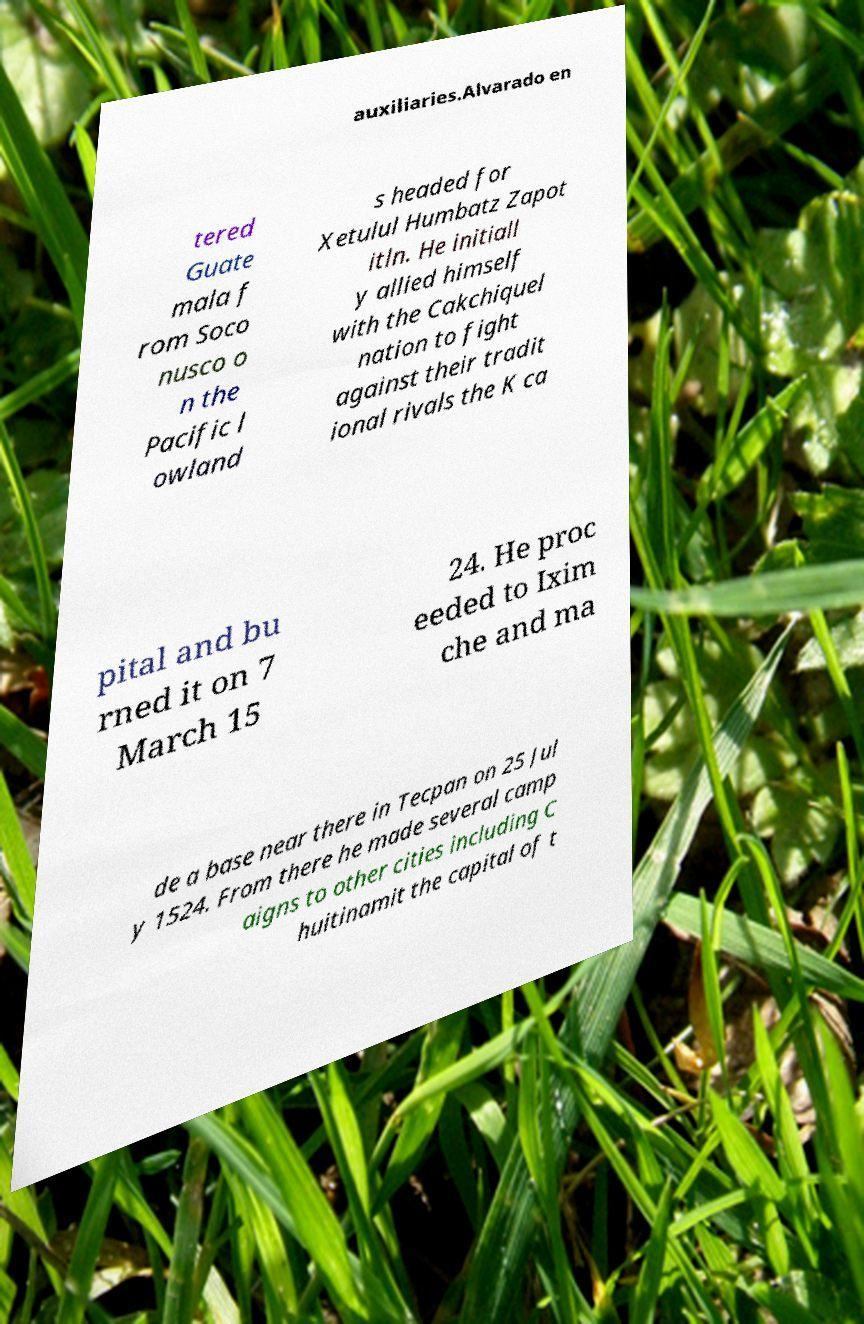Can you read and provide the text displayed in the image?This photo seems to have some interesting text. Can you extract and type it out for me? auxiliaries.Alvarado en tered Guate mala f rom Soco nusco o n the Pacific l owland s headed for Xetulul Humbatz Zapot itln. He initiall y allied himself with the Cakchiquel nation to fight against their tradit ional rivals the K ca pital and bu rned it on 7 March 15 24. He proc eeded to Ixim che and ma de a base near there in Tecpan on 25 Jul y 1524. From there he made several camp aigns to other cities including C huitinamit the capital of t 